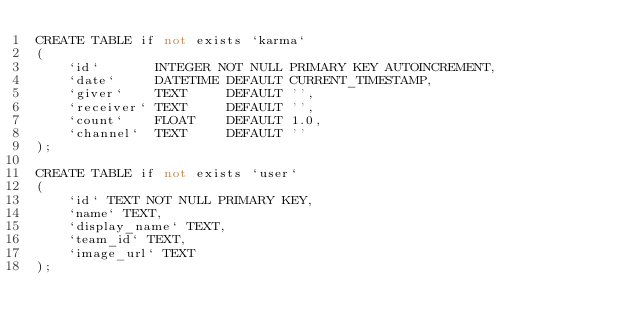<code> <loc_0><loc_0><loc_500><loc_500><_SQL_>CREATE TABLE if not exists `karma`
(
    `id`       INTEGER NOT NULL PRIMARY KEY AUTOINCREMENT,
    `date`     DATETIME DEFAULT CURRENT_TIMESTAMP,
    `giver`    TEXT     DEFAULT '',
    `receiver` TEXT     DEFAULT '',
    `count`    FLOAT    DEFAULT 1.0,
    `channel`  TEXT     DEFAULT ''
);

CREATE TABLE if not exists `user`
(
    `id` TEXT NOT NULL PRIMARY KEY,
    `name` TEXT,
    `display_name` TEXT,
    `team_id` TEXT,
    `image_url` TEXT
);
</code> 